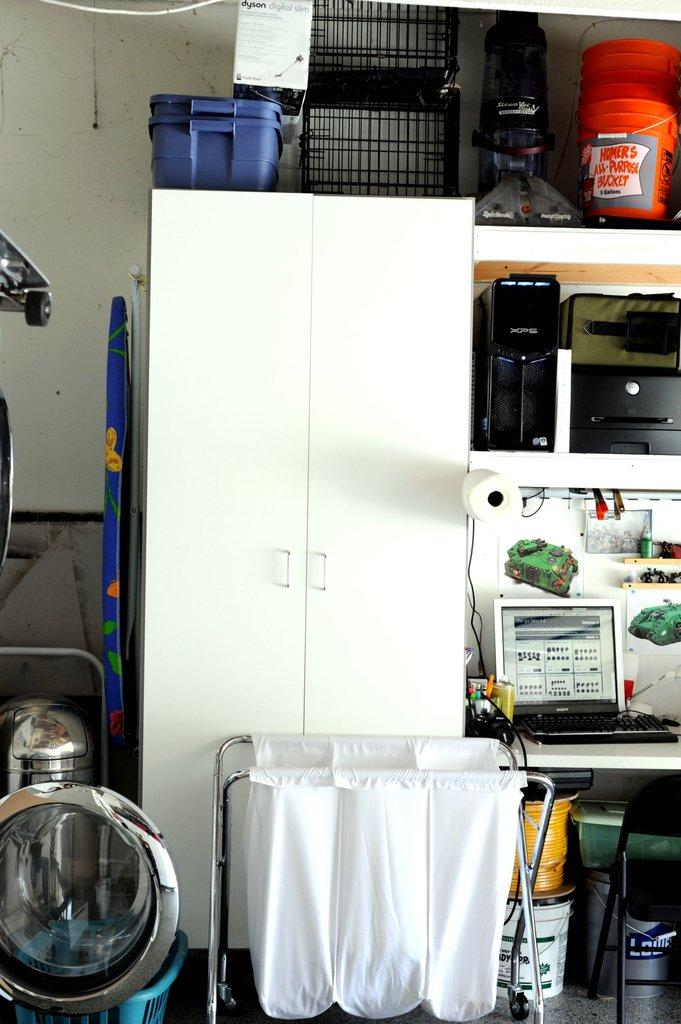Provide a one-sentence caption for the provided image. A storage room with disarray of things are shown including a white cabinet, hamper, and shelves with a bucket that says "Homer's All Purpose bucket.". 